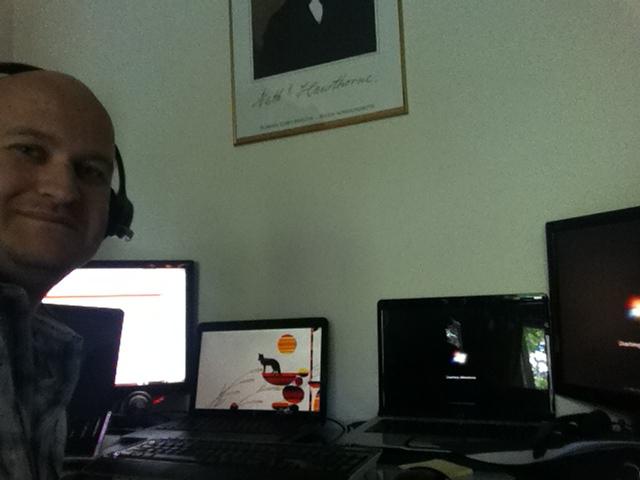What is sitting on the desk in front of the laptop?
Answer briefly. Man. Is the person male or female?
Short answer required. Male. Does the man have long hair?
Be succinct. No. Is the man on the left bald?
Write a very short answer. Yes. Are they doing a competitive activity?
Keep it brief. No. What is playing on the computer?
Write a very short answer. Music. Is the light on?
Be succinct. No. How many pictures on the wall?
Quick response, please. 1. What does the man wear on his face?
Concise answer only. Headphones. Is that a man watching?
Write a very short answer. Yes. What is on this persons head?
Keep it brief. Headphones. How many of the computer monitors have anti-glare screens?
Be succinct. 3. 